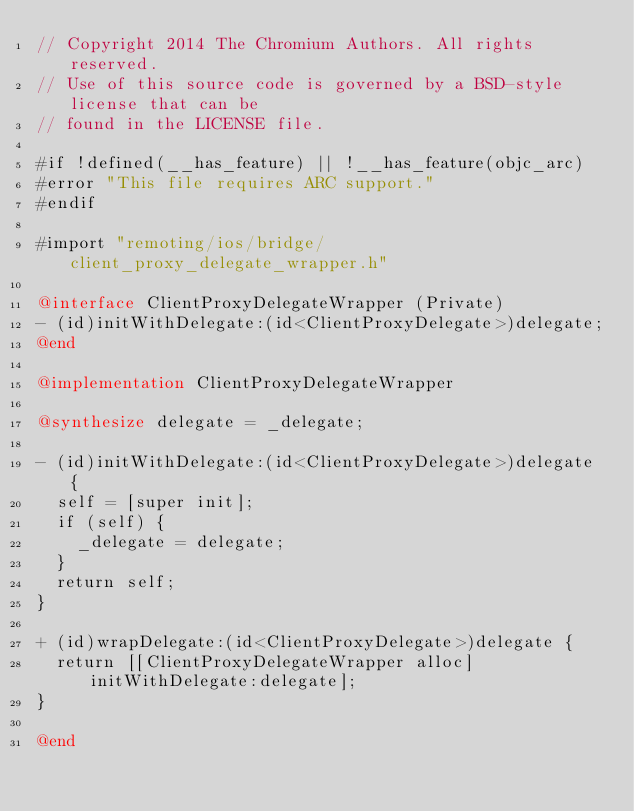<code> <loc_0><loc_0><loc_500><loc_500><_ObjectiveC_>// Copyright 2014 The Chromium Authors. All rights reserved.
// Use of this source code is governed by a BSD-style license that can be
// found in the LICENSE file.

#if !defined(__has_feature) || !__has_feature(objc_arc)
#error "This file requires ARC support."
#endif

#import "remoting/ios/bridge/client_proxy_delegate_wrapper.h"

@interface ClientProxyDelegateWrapper (Private)
- (id)initWithDelegate:(id<ClientProxyDelegate>)delegate;
@end

@implementation ClientProxyDelegateWrapper

@synthesize delegate = _delegate;

- (id)initWithDelegate:(id<ClientProxyDelegate>)delegate {
  self = [super init];
  if (self) {
    _delegate = delegate;
  }
  return self;
}

+ (id)wrapDelegate:(id<ClientProxyDelegate>)delegate {
  return [[ClientProxyDelegateWrapper alloc] initWithDelegate:delegate];
}

@end
</code> 